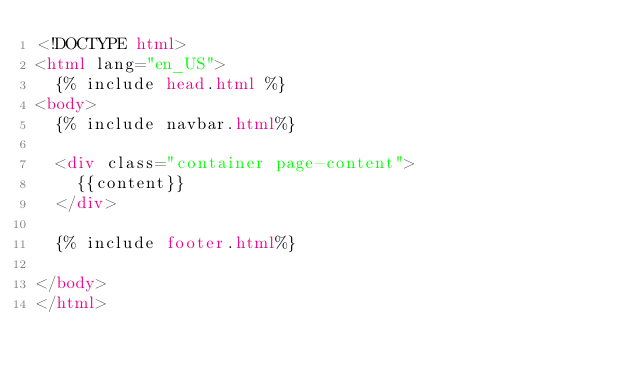<code> <loc_0><loc_0><loc_500><loc_500><_HTML_><!DOCTYPE html>
<html lang="en_US">
  {% include head.html %}
<body>
  {% include navbar.html%}

  <div class="container page-content">
    {{content}}
  </div>

  {% include footer.html%}

</body>
</html>
</code> 